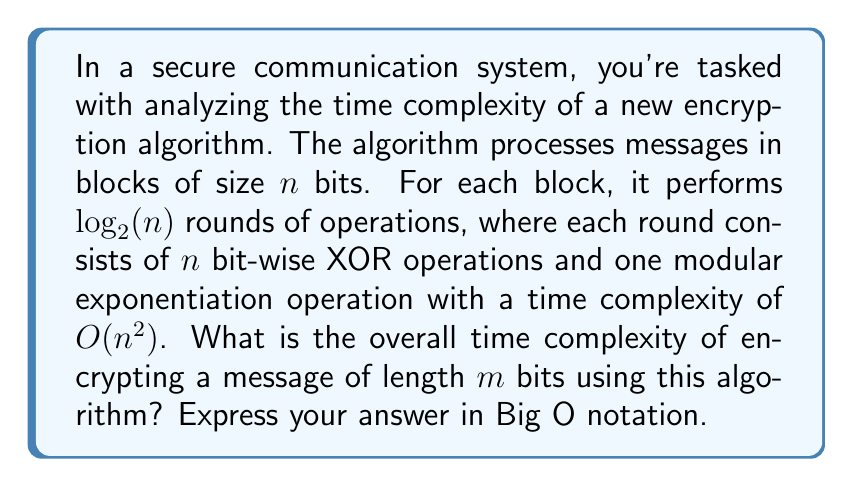Solve this math problem. Let's break down the problem and analyze it step by step:

1) First, we need to determine how many blocks of size $n$ are in a message of length $m$:
   Number of blocks = $\lceil\frac{m}{n}\rceil$

2) For each block, the algorithm performs $\log_2(n)$ rounds.

3) In each round, we have:
   - $n$ bit-wise XOR operations, each with $O(1)$ complexity
   - One modular exponentiation with $O(n^2)$ complexity

4) The time complexity for processing one block is:
   $$T_{block} = \log_2(n) \cdot (O(n) + O(n^2)) = O(n^2 \log n)$$

5) For the entire message, we multiply this by the number of blocks:
   $$T_{total} = \lceil\frac{m}{n}\rceil \cdot O(n^2 \log n)$$

6) In the worst case, $\lceil\frac{m}{n}\rceil = \frac{m}{n} + 1$, so:
   $$T_{total} = O((m + n) \cdot n \log n)$$

7) Since $n$ is the block size and typically much smaller than $m$, we can simplify this to:
   $$T_{total} = O(m \cdot n \log n)$$

This represents the overall time complexity of encrypting a message of length $m$ bits using the described algorithm.
Answer: $O(m \cdot n \log n)$ 